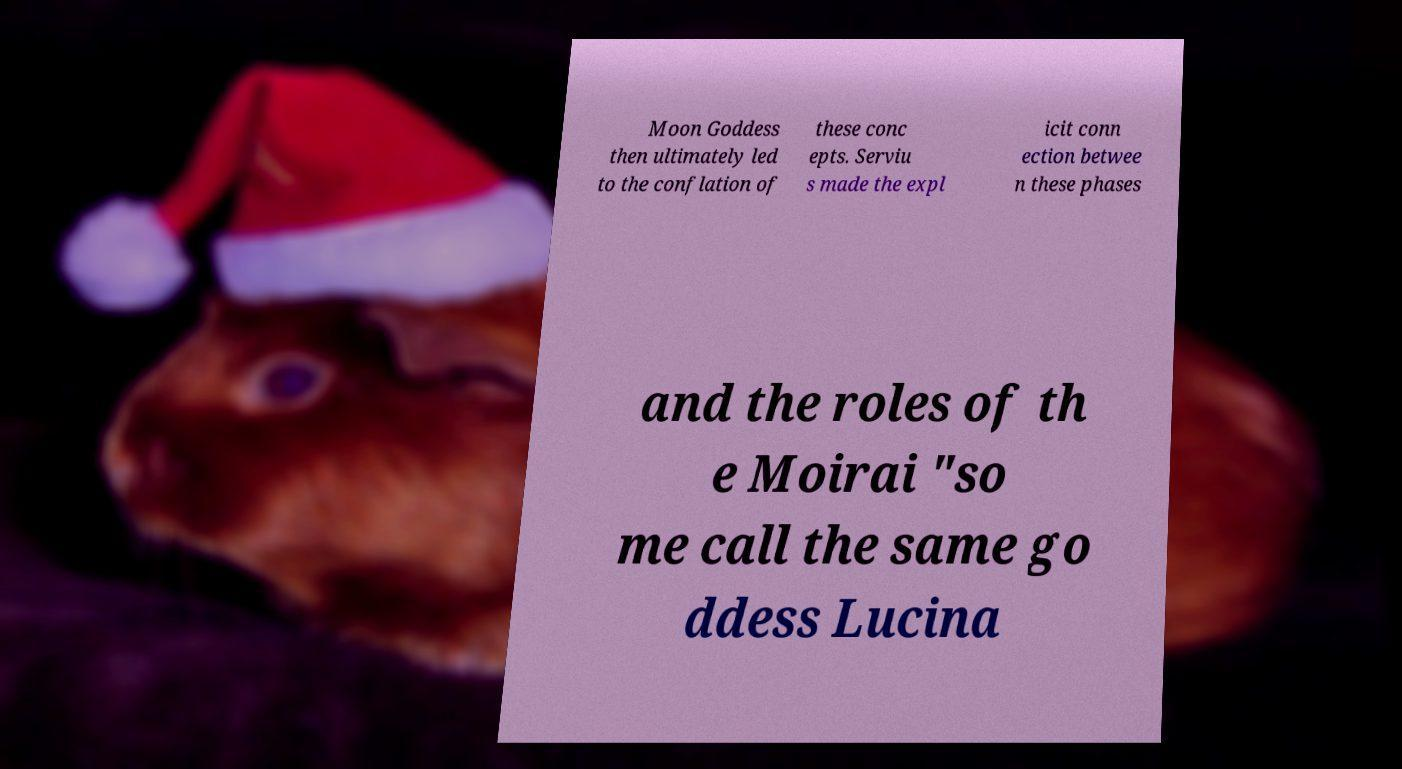Could you assist in decoding the text presented in this image and type it out clearly? Moon Goddess then ultimately led to the conflation of these conc epts. Serviu s made the expl icit conn ection betwee n these phases and the roles of th e Moirai "so me call the same go ddess Lucina 